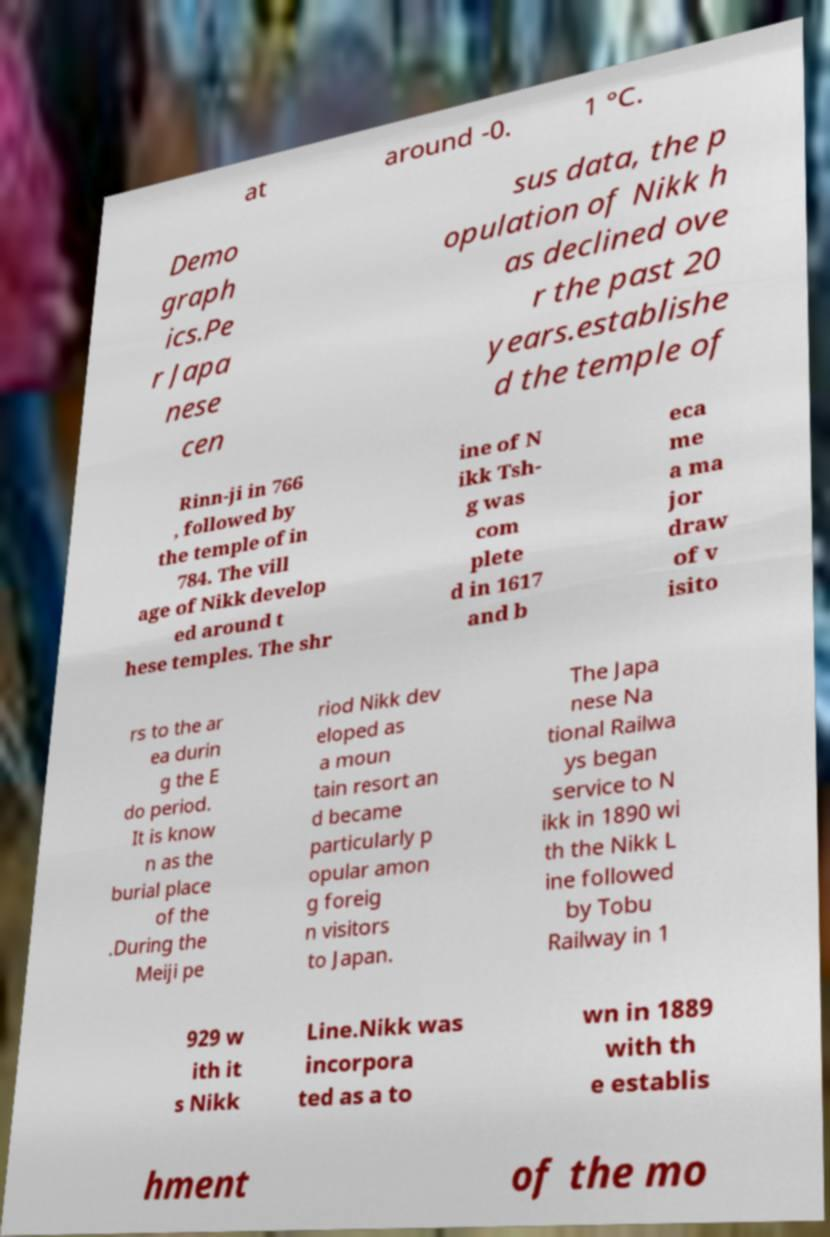For documentation purposes, I need the text within this image transcribed. Could you provide that? at around -0. 1 °C. Demo graph ics.Pe r Japa nese cen sus data, the p opulation of Nikk h as declined ove r the past 20 years.establishe d the temple of Rinn-ji in 766 , followed by the temple of in 784. The vill age of Nikk develop ed around t hese temples. The shr ine of N ikk Tsh- g was com plete d in 1617 and b eca me a ma jor draw of v isito rs to the ar ea durin g the E do period. It is know n as the burial place of the .During the Meiji pe riod Nikk dev eloped as a moun tain resort an d became particularly p opular amon g foreig n visitors to Japan. The Japa nese Na tional Railwa ys began service to N ikk in 1890 wi th the Nikk L ine followed by Tobu Railway in 1 929 w ith it s Nikk Line.Nikk was incorpora ted as a to wn in 1889 with th e establis hment of the mo 